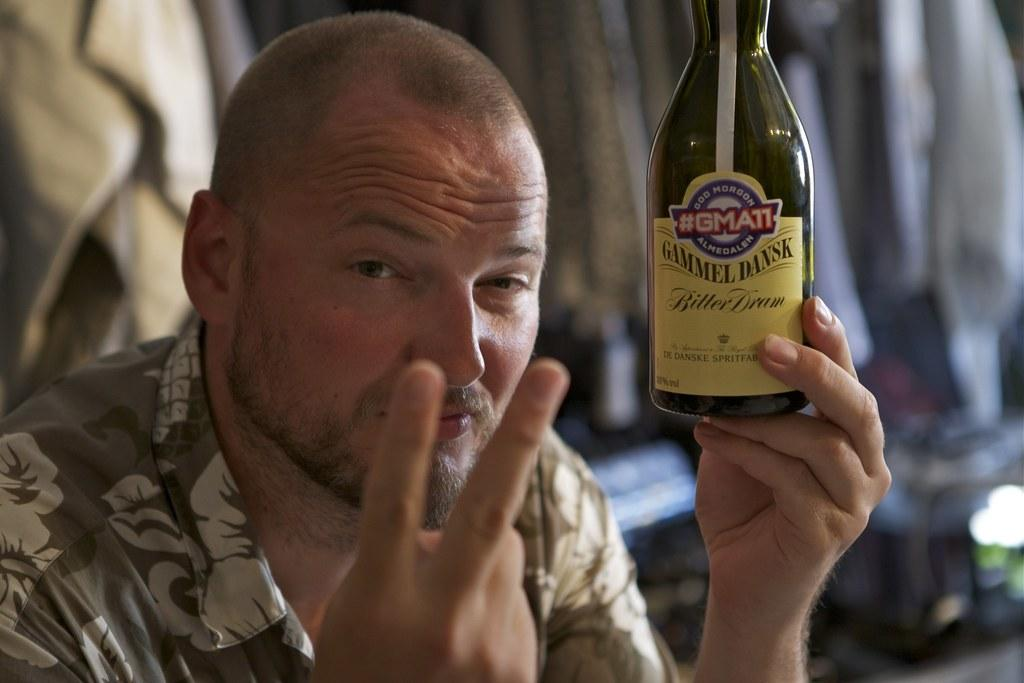What is the main subject of the image? The main subject of the image is a man. What is the man holding in one hand? The man is holding a bottle in one hand. Can you describe the man's clothing in the image? The man is wearing a flower pattern shirt. Is the man in the image asking for credit from a bank? There is no indication in the image that the man is asking for credit from a bank. What type of pipe is the man smoking in the image? There is no pipe present in the image. 